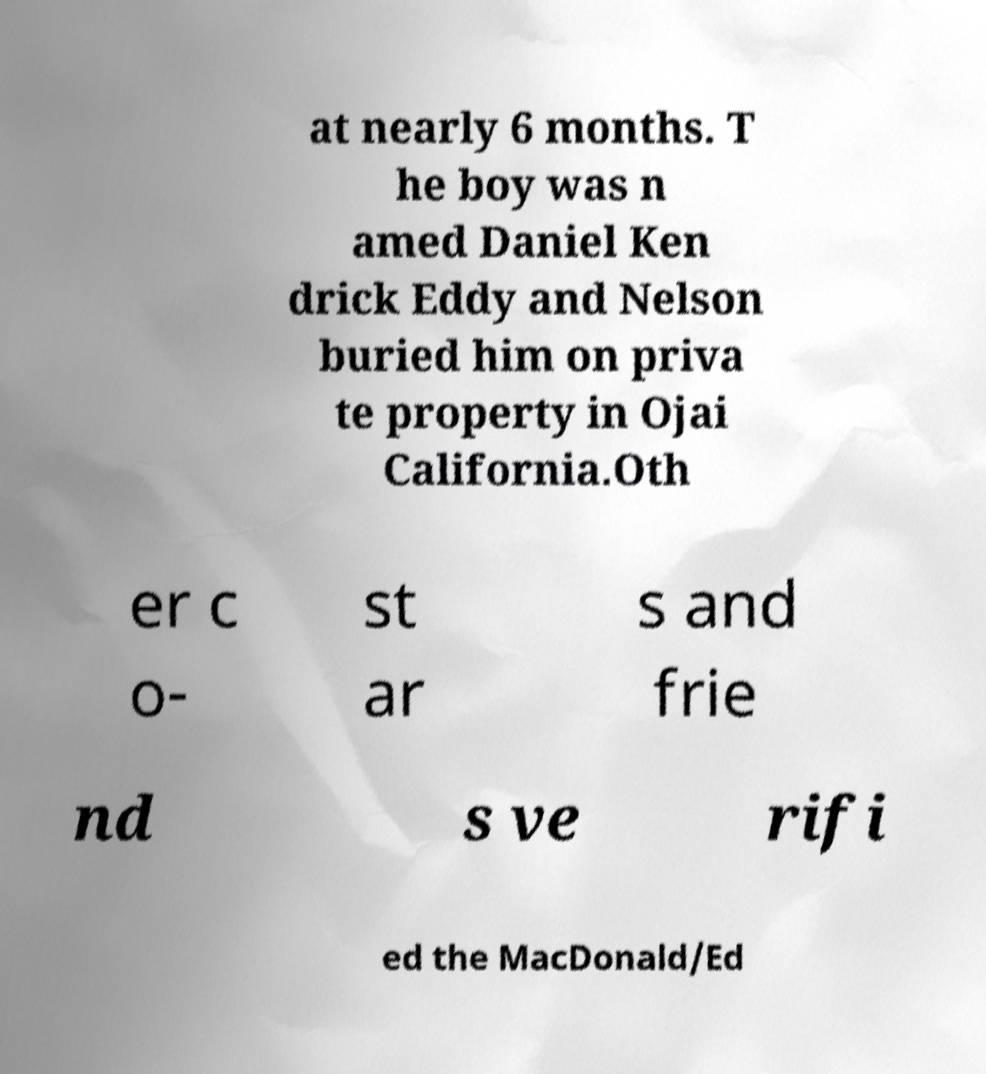I need the written content from this picture converted into text. Can you do that? at nearly 6 months. T he boy was n amed Daniel Ken drick Eddy and Nelson buried him on priva te property in Ojai California.Oth er c o- st ar s and frie nd s ve rifi ed the MacDonald/Ed 